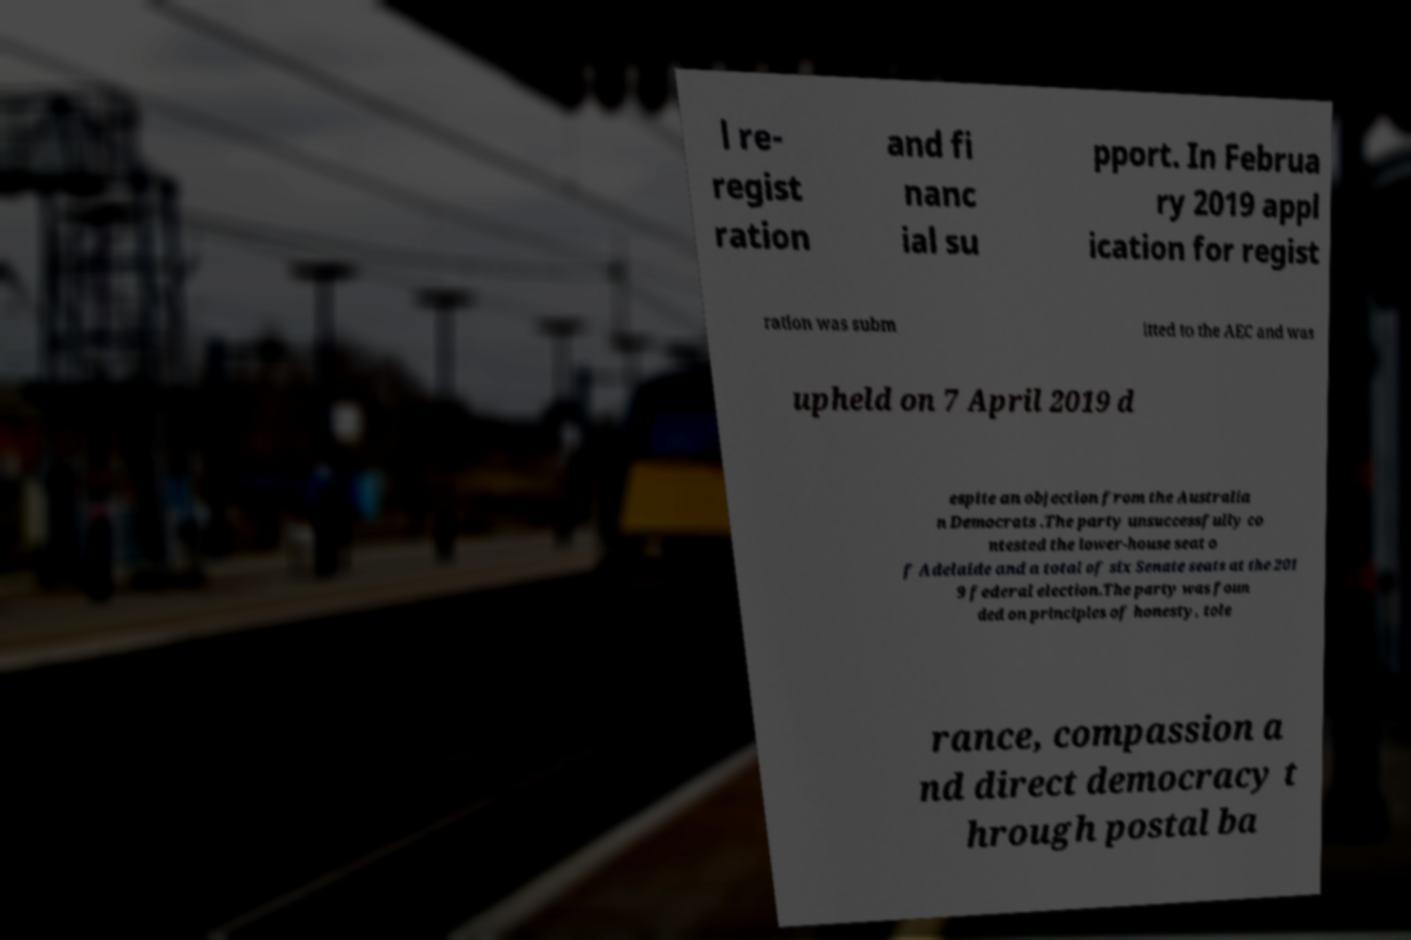For documentation purposes, I need the text within this image transcribed. Could you provide that? l re- regist ration and fi nanc ial su pport. In Februa ry 2019 appl ication for regist ration was subm itted to the AEC and was upheld on 7 April 2019 d espite an objection from the Australia n Democrats .The party unsuccessfully co ntested the lower-house seat o f Adelaide and a total of six Senate seats at the 201 9 federal election.The party was foun ded on principles of honesty, tole rance, compassion a nd direct democracy t hrough postal ba 